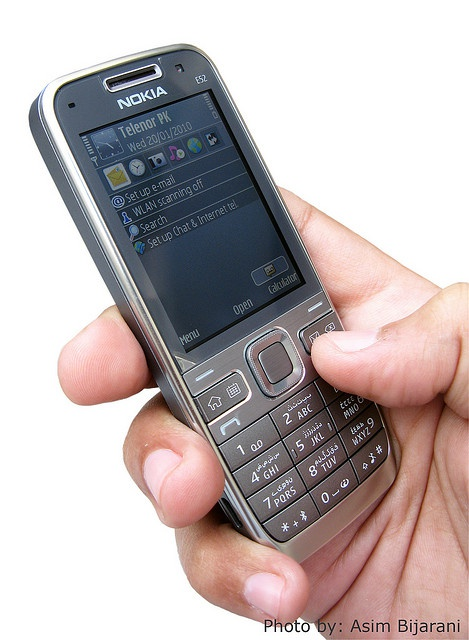Describe the objects in this image and their specific colors. I can see cell phone in white, gray, black, navy, and darkgray tones and people in white, lightpink, pink, and brown tones in this image. 